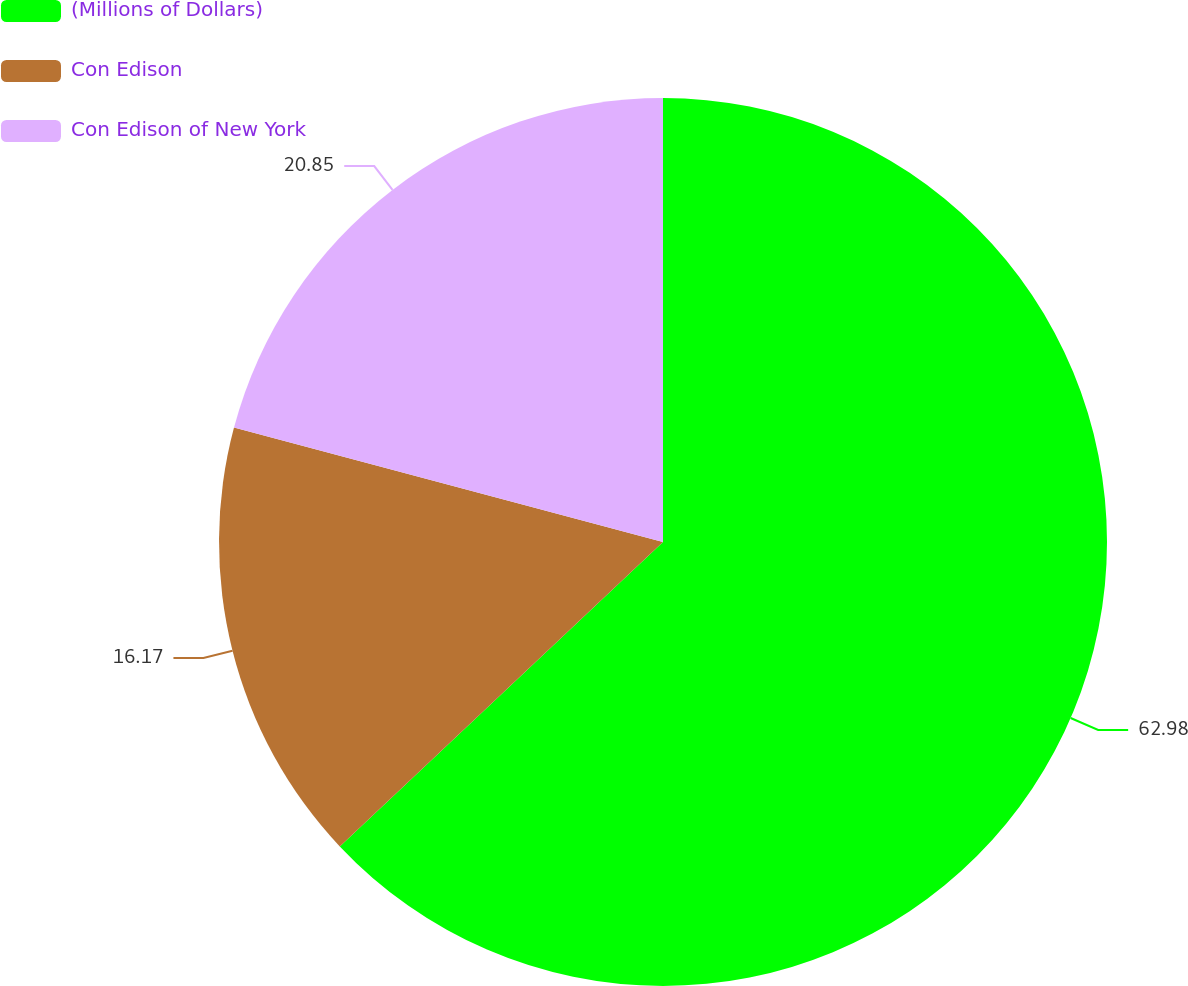<chart> <loc_0><loc_0><loc_500><loc_500><pie_chart><fcel>(Millions of Dollars)<fcel>Con Edison<fcel>Con Edison of New York<nl><fcel>62.97%<fcel>16.17%<fcel>20.85%<nl></chart> 